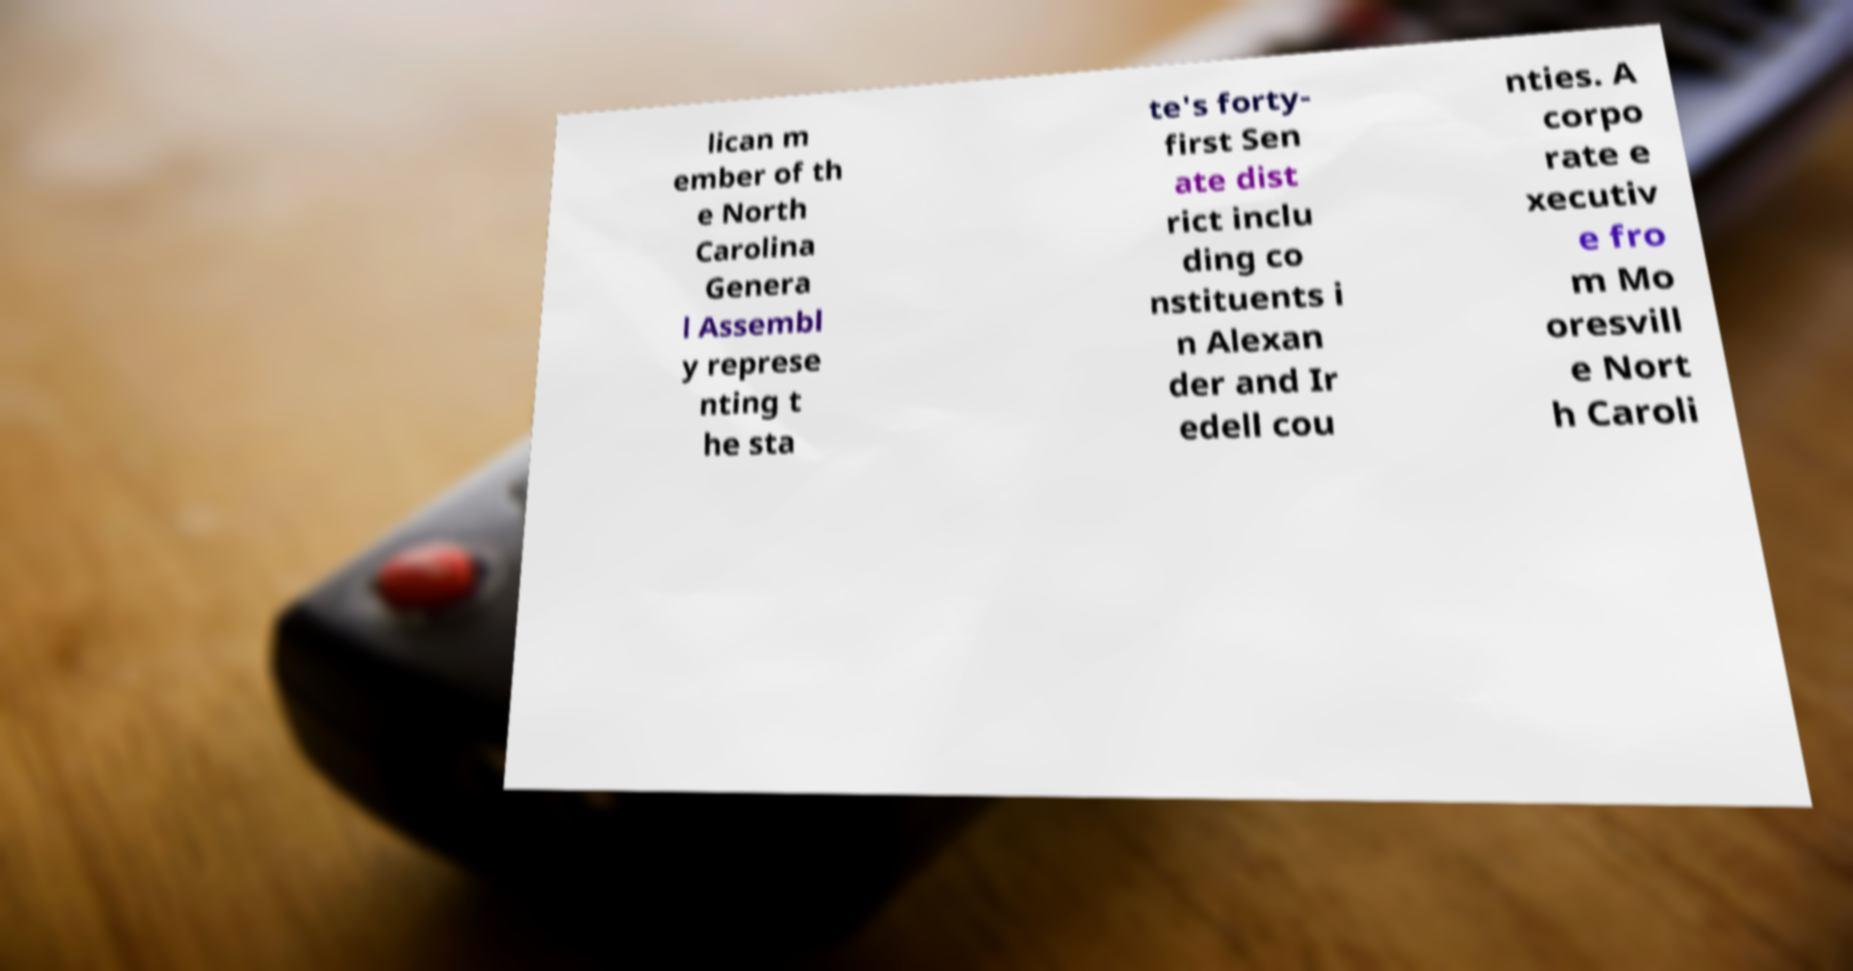Can you accurately transcribe the text from the provided image for me? lican m ember of th e North Carolina Genera l Assembl y represe nting t he sta te's forty- first Sen ate dist rict inclu ding co nstituents i n Alexan der and Ir edell cou nties. A corpo rate e xecutiv e fro m Mo oresvill e Nort h Caroli 